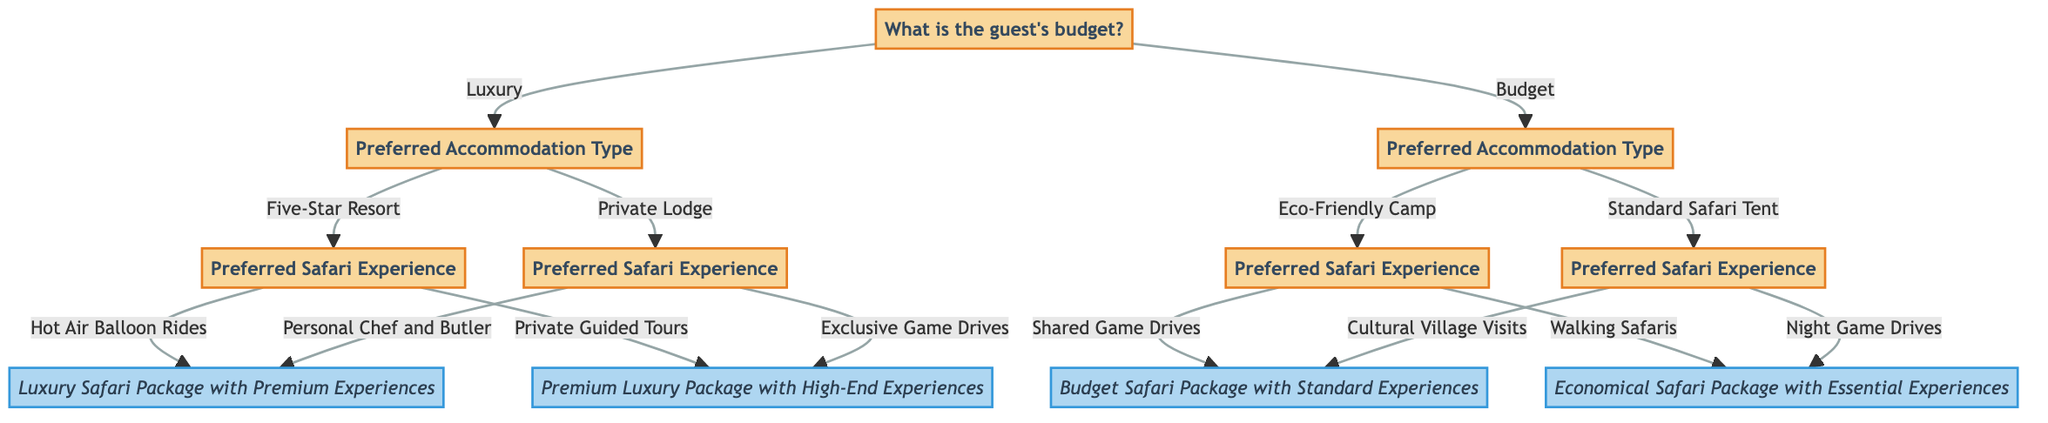What is the first question in the diagram? The first question is about the guest's budget, which offers two options: "Luxury" and "Budget".
Answer: What is the guest's budget? How many nodes are in the decision tree? The decision tree contains 11 nodes, including both questions and results, from the initial budget question to the final packages offered.
Answer: 11 nodes What follows if the guest selects "Private Lodge"? If the guest selects "Private Lodge", the next question would be about their preferred safari experience, leading to two options: "Personal Chef and Butler" or "Exclusive Game Drives".
Answer: Preferred Safari Experience What result is obtained from choosing "Hot Air Balloon Rides"? Choosing "Hot Air Balloon Rides" leads to the result of a "Luxury Safari Package with Premium Experiences", which is one of the highly suggested luxury options.
Answer: Luxury Safari Package with Premium Experiences What does the option "Walking Safaris" yield? Selecting "Walking Safaris" results in the "Economical Safari Package with Essential Experiences", which is designed for budget travelers.
Answer: Economical Safari Package with Essential Experiences How many options are available after choosing "Budget" for accommodation type? After selecting "Budget", there are two options available for accommodation type: "Eco-Friendly Camp" and "Standard Safari Tent".
Answer: 2 options If a guest chooses "Five-Star Resort", what does it lead to? Choosing "Five-Star Resort" leads to a follow-up question about preferred safari experiences, which further narrows down to either "Hot Air Balloon Rides" or "Private Guided Tours".
Answer: Preferred Safari Experience What are the last outcomes for the budget category? The outcomes for the budget category are "Budget Safari Package with Standard Experiences" and "Economical Safari Package with Essential Experiences", which result from different experience choices.
Answer: 2 outcomes 